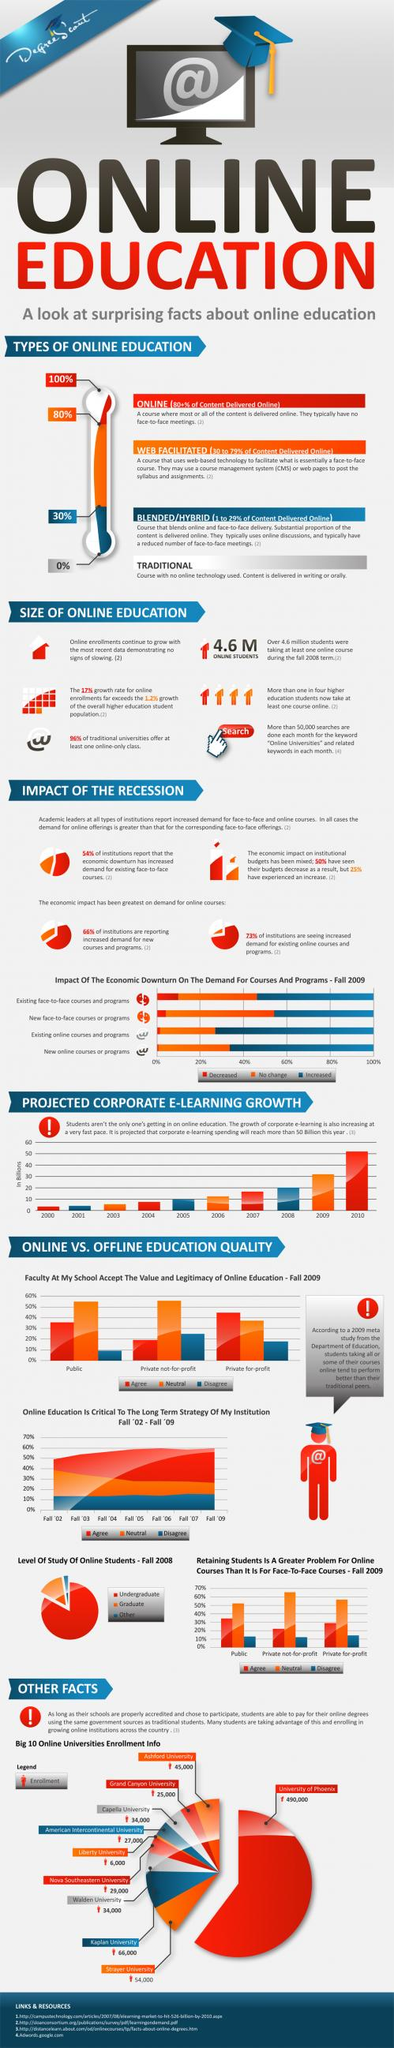Give some essential details in this illustration. Traditional learning modes deliver 100% of the content in either oral or written formats. 